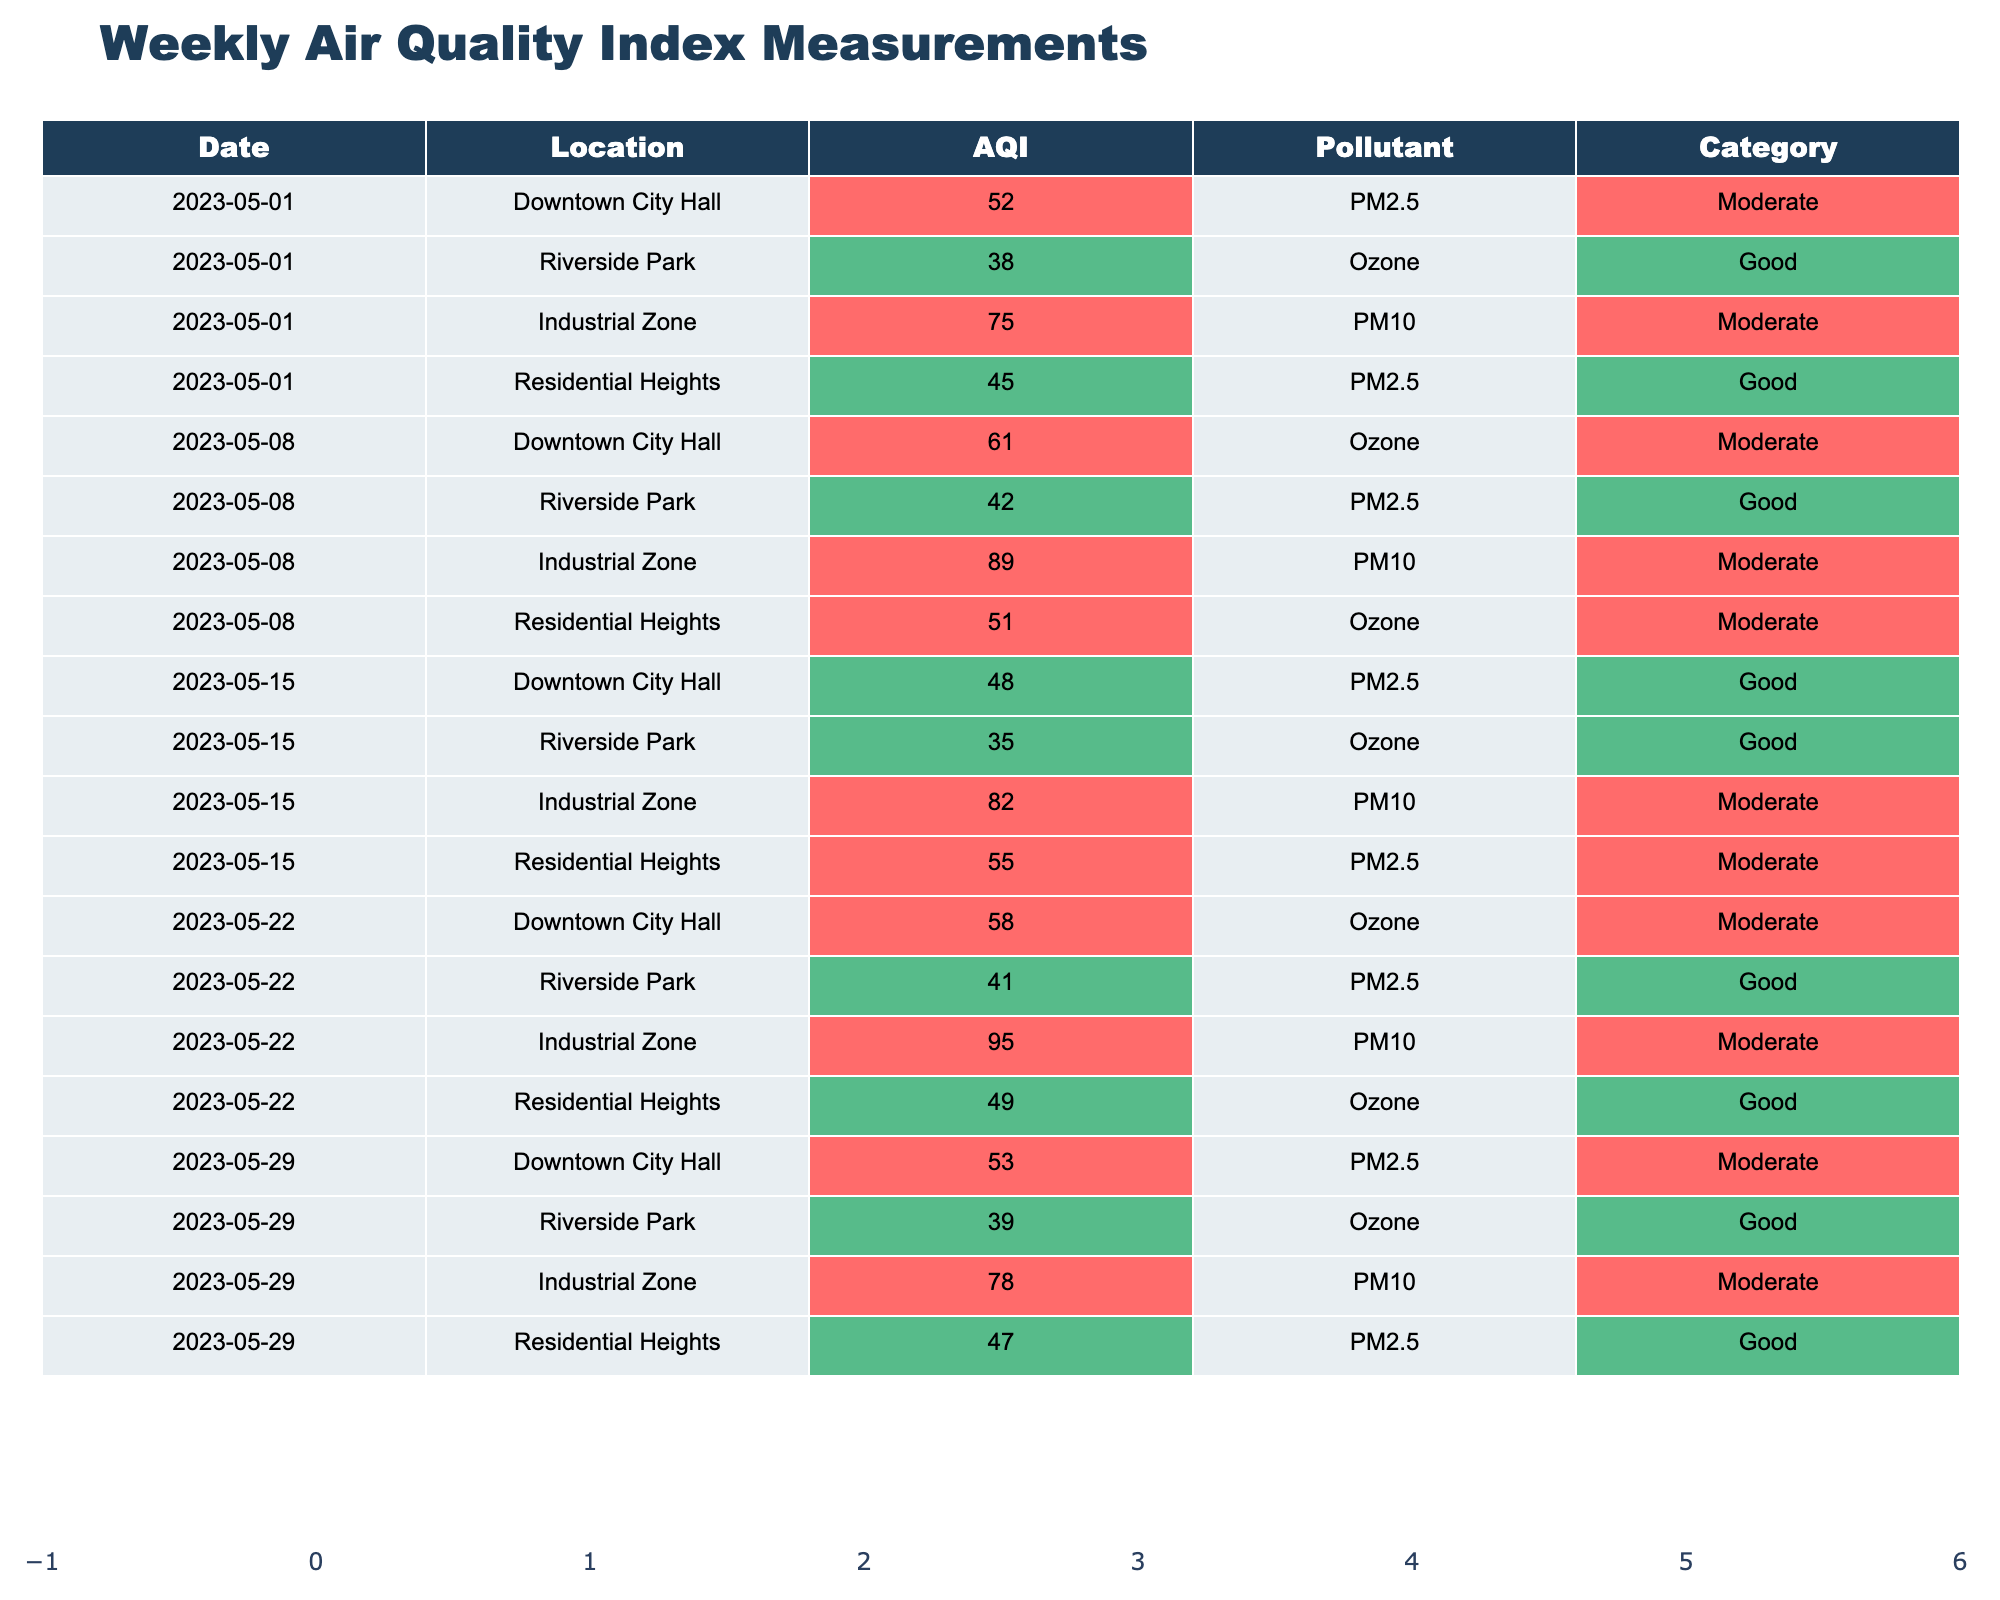What was the air quality index for Residential Heights on May 22, 2023? From the table, for the date May 22, 2023, the AQI for Residential Heights is 49.
Answer: 49 What is the highest AQI recorded for Industrial Zone over the given period? By reviewing the table, the highest AQI for Industrial Zone is 95 on May 22, 2023.
Answer: 95 How many times did Downtown City Hall have an AQI in the "Good" category? Downtown City Hall had an AQI in the "Good" category once, specifically on May 15, 2023, with an AQI of 48.
Answer: 1 What is the average AQI for Riverside Park over the recorded dates? The AQI values for Riverside Park are 38, 42, 35, 41, and 39. The sum of these is 195. There are 5 measurements, so the average is 195/5 = 39.
Answer: 39 Did the AQI for Residential Heights ever reach the "Moderate" category? Yes, the AQI for Residential Heights reached the "Moderate" category on May 15, 2023, with an AQI of 55.
Answer: Yes Which location had the worst air quality on May 8, 2023? On May 8, 2023, the worst AQI was for Industrial Zone at 89, which is the highest value compared to other locations for that date.
Answer: Industrial Zone What is the trend of the AQI for Downtown City Hall across the recorded weeks? The AQI values for Downtown City Hall over the weeks are 52, 61, 48, 58, and 53. This data shows variability but does not indicate a clear upward or downward trend, as values fluctuate.
Answer: Variable How many days had an AQI value of 75 or higher, and where did they occur? The AQI values of 75 or higher occurred on 3 separate days: May 1 (75 at Industrial Zone), May 8 (89 at Industrial Zone), and May 22 (95 at Industrial Zone).
Answer: 3 days For which location did the AQI improve the most from May 1 to May 29, 2023? For Downtown City Hall, the AQI improved from 52 on May 1 to 53 on May 29, which is an improvement of 1. However, Riverside Park improved from 38 to 39, which is also an improvement of 1. Thus, there was minimal improvement overall.
Answer: None significantly improved What is the total number of "Good" category measurements across all dates and locations? Reviewing all the entries, the "Good" category measurements are: Residential Heights (2), Riverside Park (4), Downtown City Hall (1). Summing these gives a total of 7 “Good” measurements.
Answer: 7 